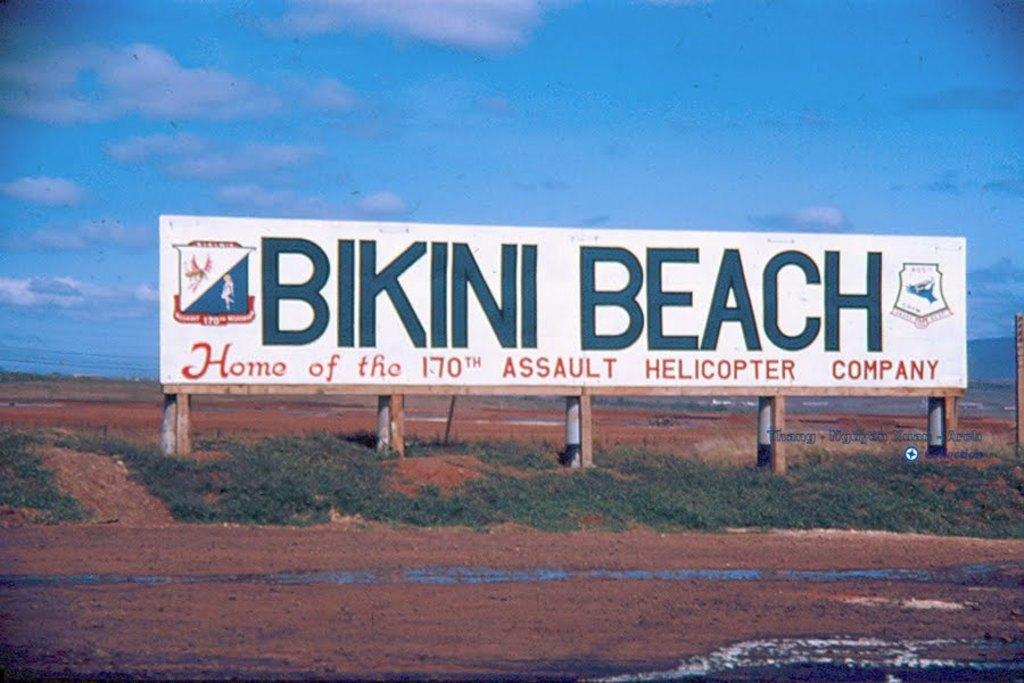<image>
Relay a brief, clear account of the picture shown. A billboard explains that Bikini Beach is home of the 170th Assault Helicopter Company. 